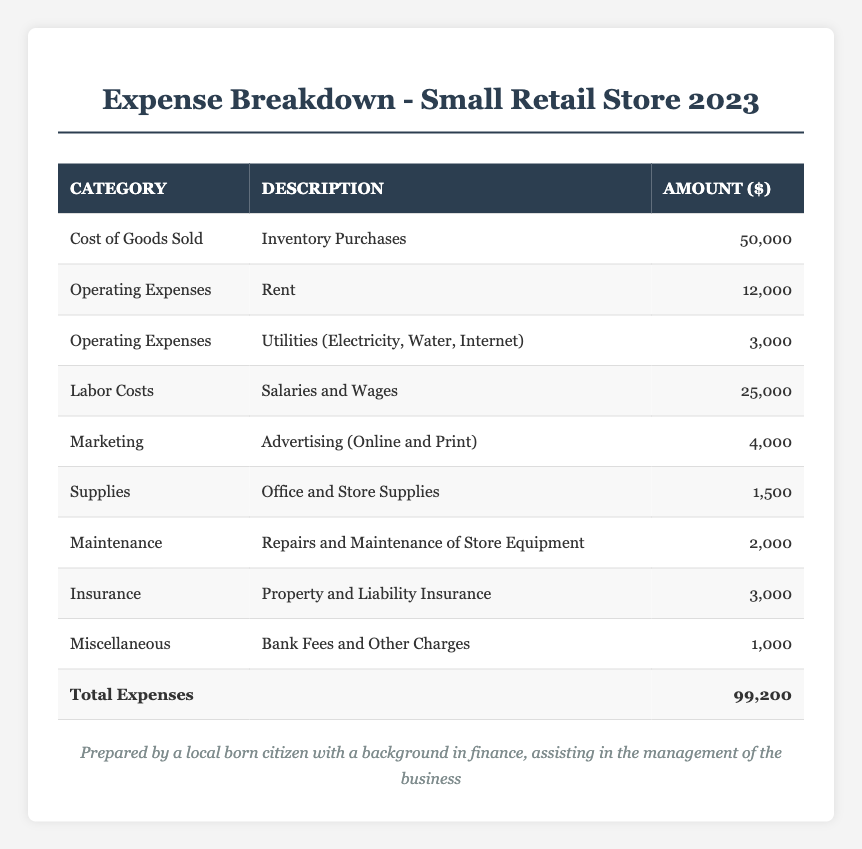What is the total amount spent on operating expenses? The operating expenses consist of rent ($12,000) and utilities ($3,000). Adding these amounts gives $12,000 + $3,000 = $15,000.
Answer: 15,000 What is the amount allocated to labor costs? The table shows that salaries and wages accounting for labor costs amount to $25,000.
Answer: 25,000 Is the total expenses amount more than $90,000? The total expenses listed in the table are $99,200, which is greater than $90,000.
Answer: Yes What is the difference between the cost of goods sold and total expenses? The cost of goods sold is $50,000. The total expenses are $99,200. Therefore, the difference is $99,200 - $50,000 = $49,200.
Answer: 49,200 How much is spent on marketing compared to maintenance? The marketing expense is $4,000, and maintenance expenses are $2,000. The difference is $4,000 - $2,000 = $2,000, meaning marketing expenses are $2,000 more.
Answer: 2,000 What percentage of the total expenses does insurance represent? Insurance costs $3,000. To find its percentage of total expenses: ($3,000 / $99,200) * 100 = approximately 3.02%.
Answer: Approximately 3.02% If we sum all expense categories, how much do we get? The sum of all expenses is already given as total expenses, which equals $99,200.
Answer: 99,200 What is the maximum overhead expense listed in the table? Among the categories, labor costs at $25,000 is the highest amount listed compared to others.
Answer: 25,000 How much is spent on miscellaneous expenses? The miscellaneous expenses amount to $1,000, as indicated directly in the table.
Answer: 1,000 Calculate the average cost for the supplies and marketing categories together. The supply expense is $1,500 and the marketing expense is $4,000. The total for both is $1,500 + $4,000 = $5,500. The average is $5,500 / 2 = $2,750.
Answer: 2,750 